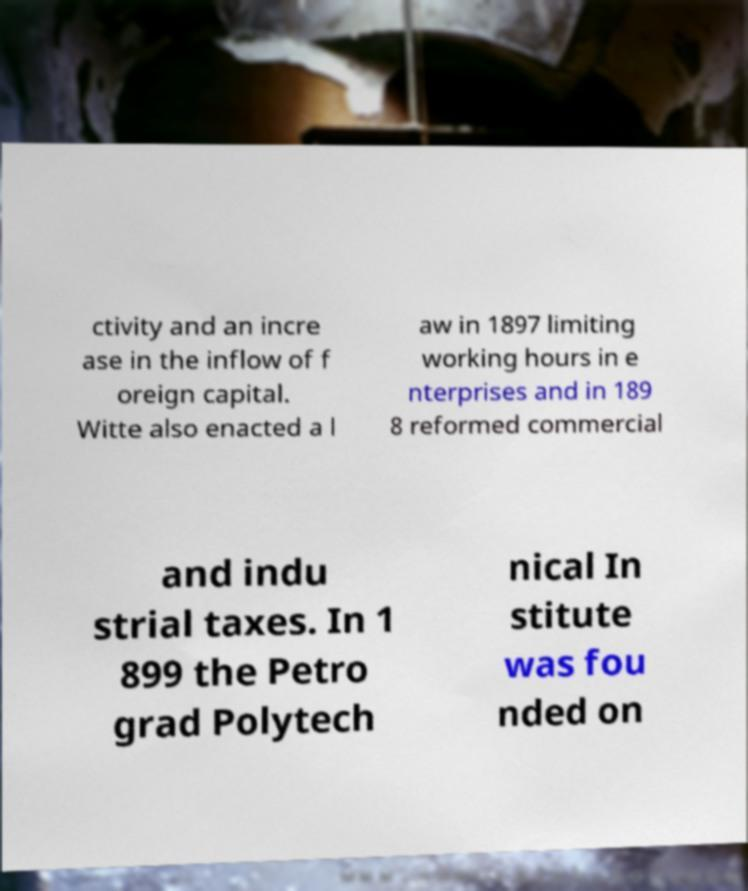Can you read and provide the text displayed in the image?This photo seems to have some interesting text. Can you extract and type it out for me? ctivity and an incre ase in the inflow of f oreign capital. Witte also enacted a l aw in 1897 limiting working hours in e nterprises and in 189 8 reformed commercial and indu strial taxes. In 1 899 the Petro grad Polytech nical In stitute was fou nded on 